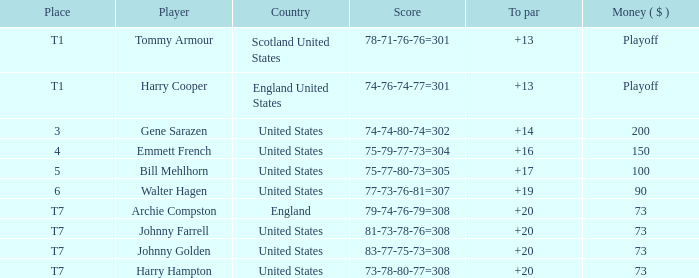What is the placement when archie compston is the contender and the currency is $73? T7. 